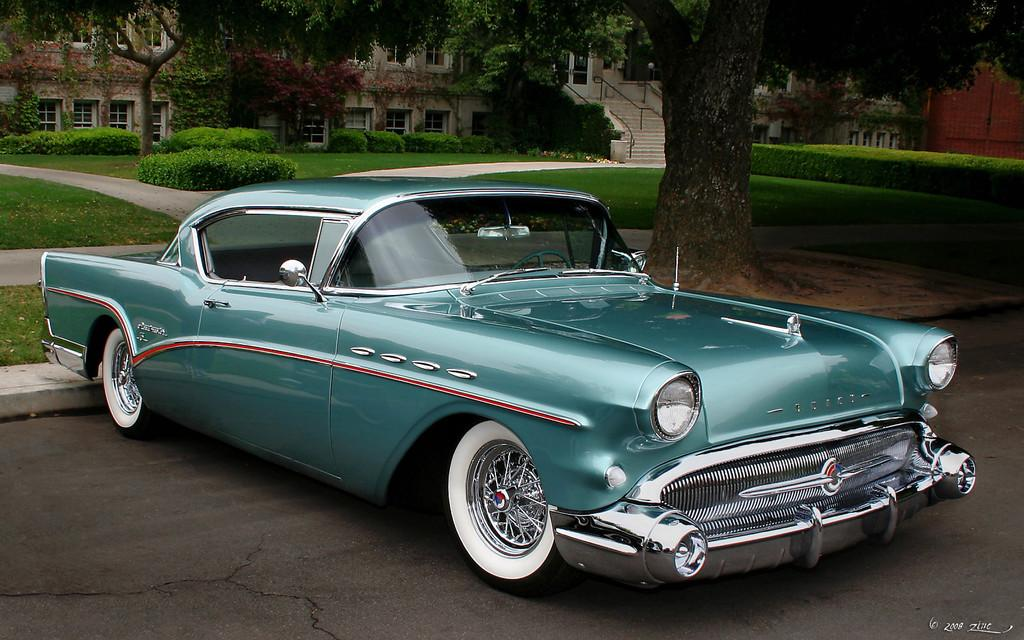What type of natural elements are present in the image? There are trees and plants in the image. What type of structure can be seen at the top of the image? There is a building at the top of the image. What mode of transportation is visible in the image? There is a car in the middle of the image. How many stems are visible on the trees in the image? The provided facts do not mention the number of stems on the trees, and therefore it cannot be determined from the image. 